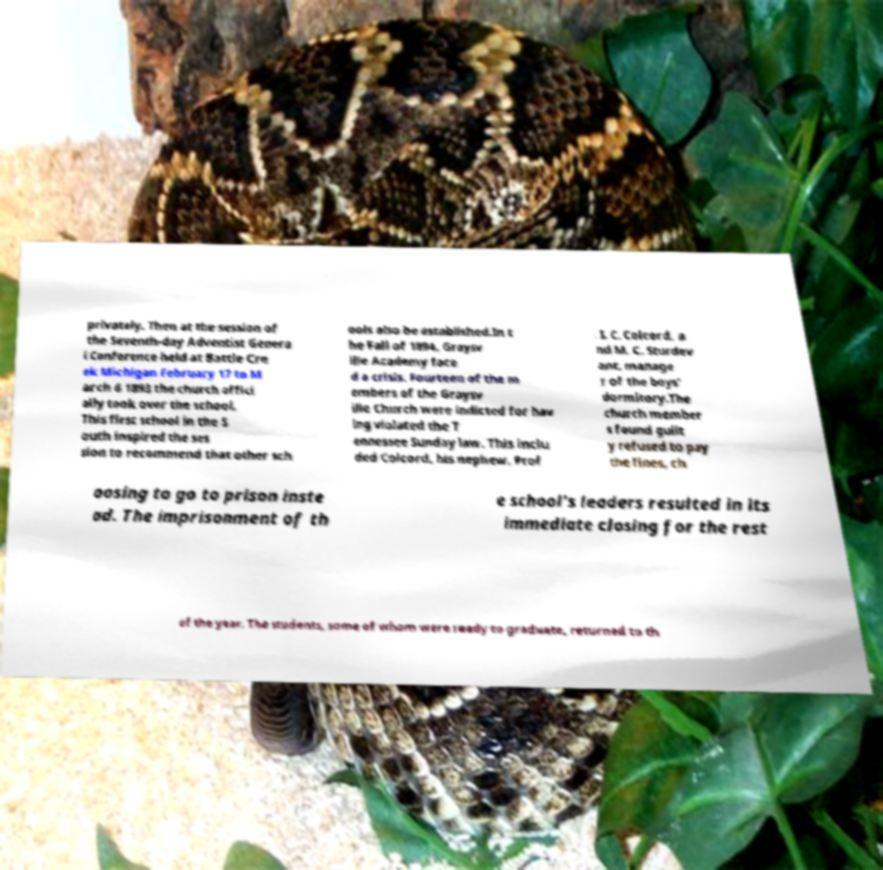Could you extract and type out the text from this image? privately. Then at the session of the Seventh-day Adventist Genera l Conference held at Battle Cre ek Michigan February 17 to M arch 6 1893 the church offici ally took over the school. This first school in the S outh inspired the ses sion to recommend that other sch ools also be established.In t he Fall of 1894, Graysv ille Academy face d a crisis. Fourteen of the m embers of the Graysv ille Church were indicted for hav ing violated the T ennessee Sunday law. This inclu ded Colcord, his nephew, Prof . I. C. Colcord, a nd M. C. Sturdev ant, manage r of the boys' dormitory.The church member s found guilt y refused to pay the fines, ch oosing to go to prison inste ad. The imprisonment of th e school's leaders resulted in its immediate closing for the rest of the year. The students, some of whom were ready to graduate, returned to th 